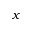<formula> <loc_0><loc_0><loc_500><loc_500>x</formula> 